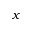<formula> <loc_0><loc_0><loc_500><loc_500>x</formula> 